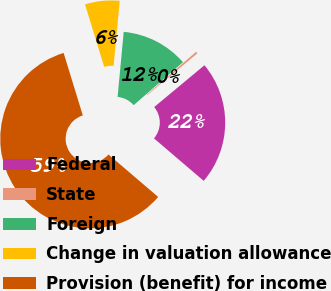Convert chart. <chart><loc_0><loc_0><loc_500><loc_500><pie_chart><fcel>Federal<fcel>State<fcel>Foreign<fcel>Change in valuation allowance<fcel>Provision (benefit) for income<nl><fcel>22.29%<fcel>0.37%<fcel>12.1%<fcel>6.23%<fcel>59.01%<nl></chart> 